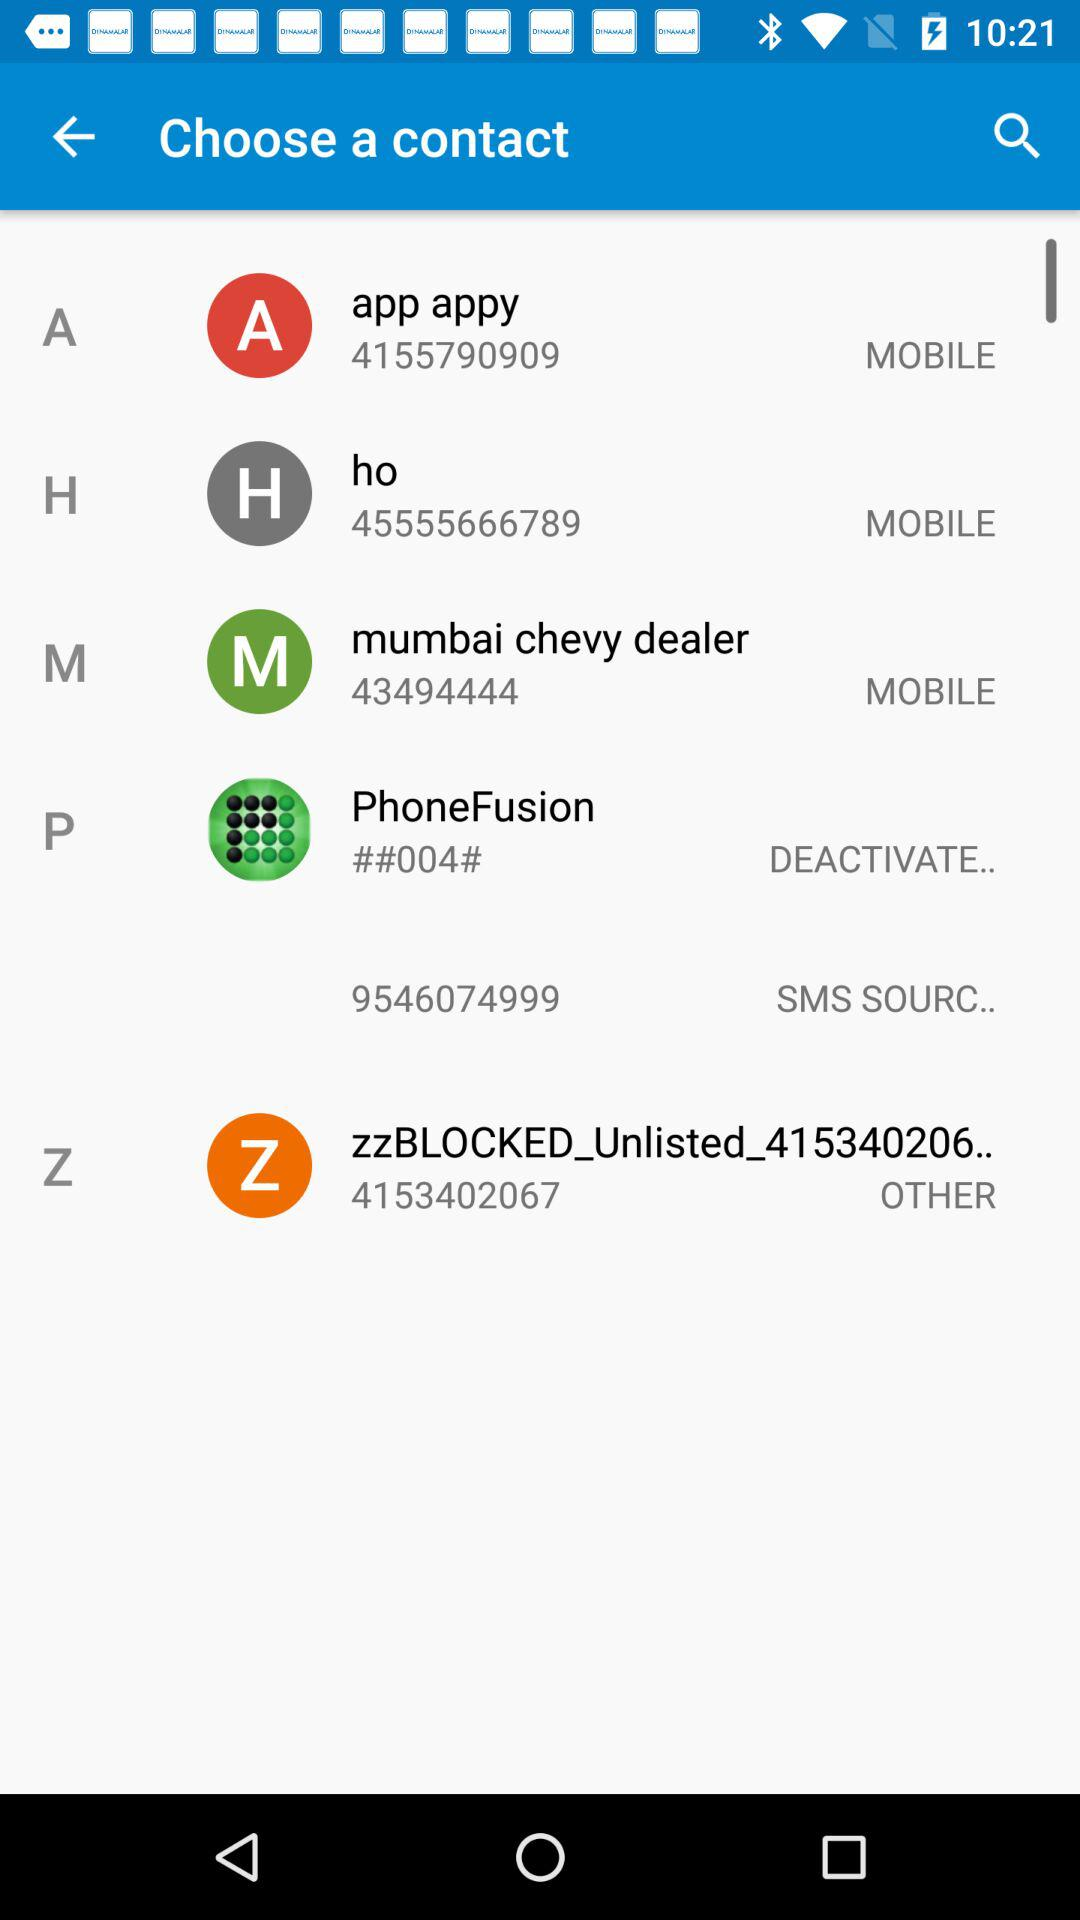What is the number with the label "SMS SOURC.."? The number with the label "SMS SOURC.." is 9546074999. 